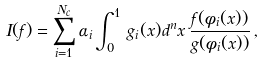Convert formula to latex. <formula><loc_0><loc_0><loc_500><loc_500>I ( f ) = \sum _ { i = 1 } ^ { N _ { c } } \alpha _ { i } \int _ { 0 } ^ { 1 } \, g _ { i } ( x ) d ^ { n } x \, \frac { f ( \phi _ { i } ( x ) ) } { g ( \phi _ { i } ( x ) ) } \, ,</formula> 